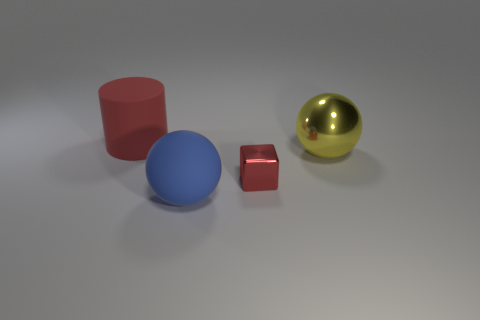Add 4 blue matte balls. How many objects exist? 8 Subtract all cubes. How many objects are left? 3 Subtract 1 red cubes. How many objects are left? 3 Subtract all cyan metallic spheres. Subtract all yellow shiny objects. How many objects are left? 3 Add 1 large cylinders. How many large cylinders are left? 2 Add 2 large purple metallic cylinders. How many large purple metallic cylinders exist? 2 